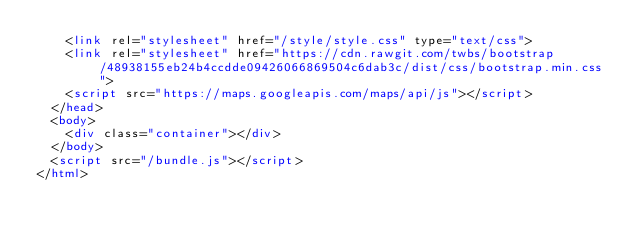Convert code to text. <code><loc_0><loc_0><loc_500><loc_500><_HTML_>    <link rel="stylesheet" href="/style/style.css" type="text/css">
    <link rel="stylesheet" href="https://cdn.rawgit.com/twbs/bootstrap/48938155eb24b4ccdde09426066869504c6dab3c/dist/css/bootstrap.min.css">
    <script src="https://maps.googleapis.com/maps/api/js"></script>
  </head>
  <body>
    <div class="container"></div>
  </body>
  <script src="/bundle.js"></script>
</html>
</code> 